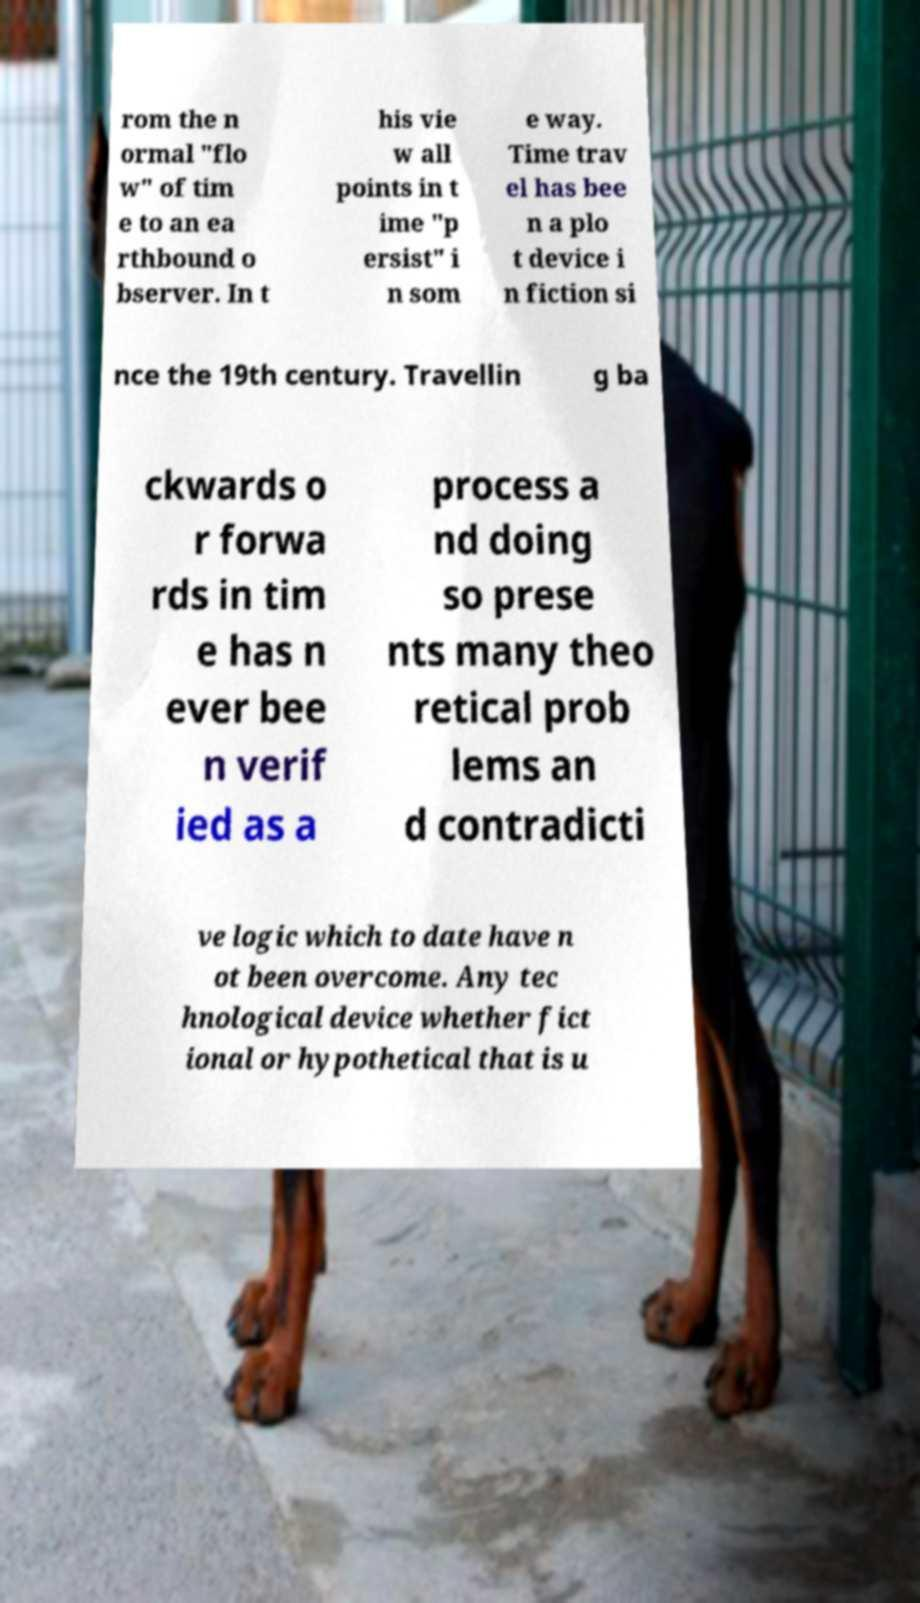I need the written content from this picture converted into text. Can you do that? rom the n ormal "flo w" of tim e to an ea rthbound o bserver. In t his vie w all points in t ime "p ersist" i n som e way. Time trav el has bee n a plo t device i n fiction si nce the 19th century. Travellin g ba ckwards o r forwa rds in tim e has n ever bee n verif ied as a process a nd doing so prese nts many theo retical prob lems an d contradicti ve logic which to date have n ot been overcome. Any tec hnological device whether fict ional or hypothetical that is u 